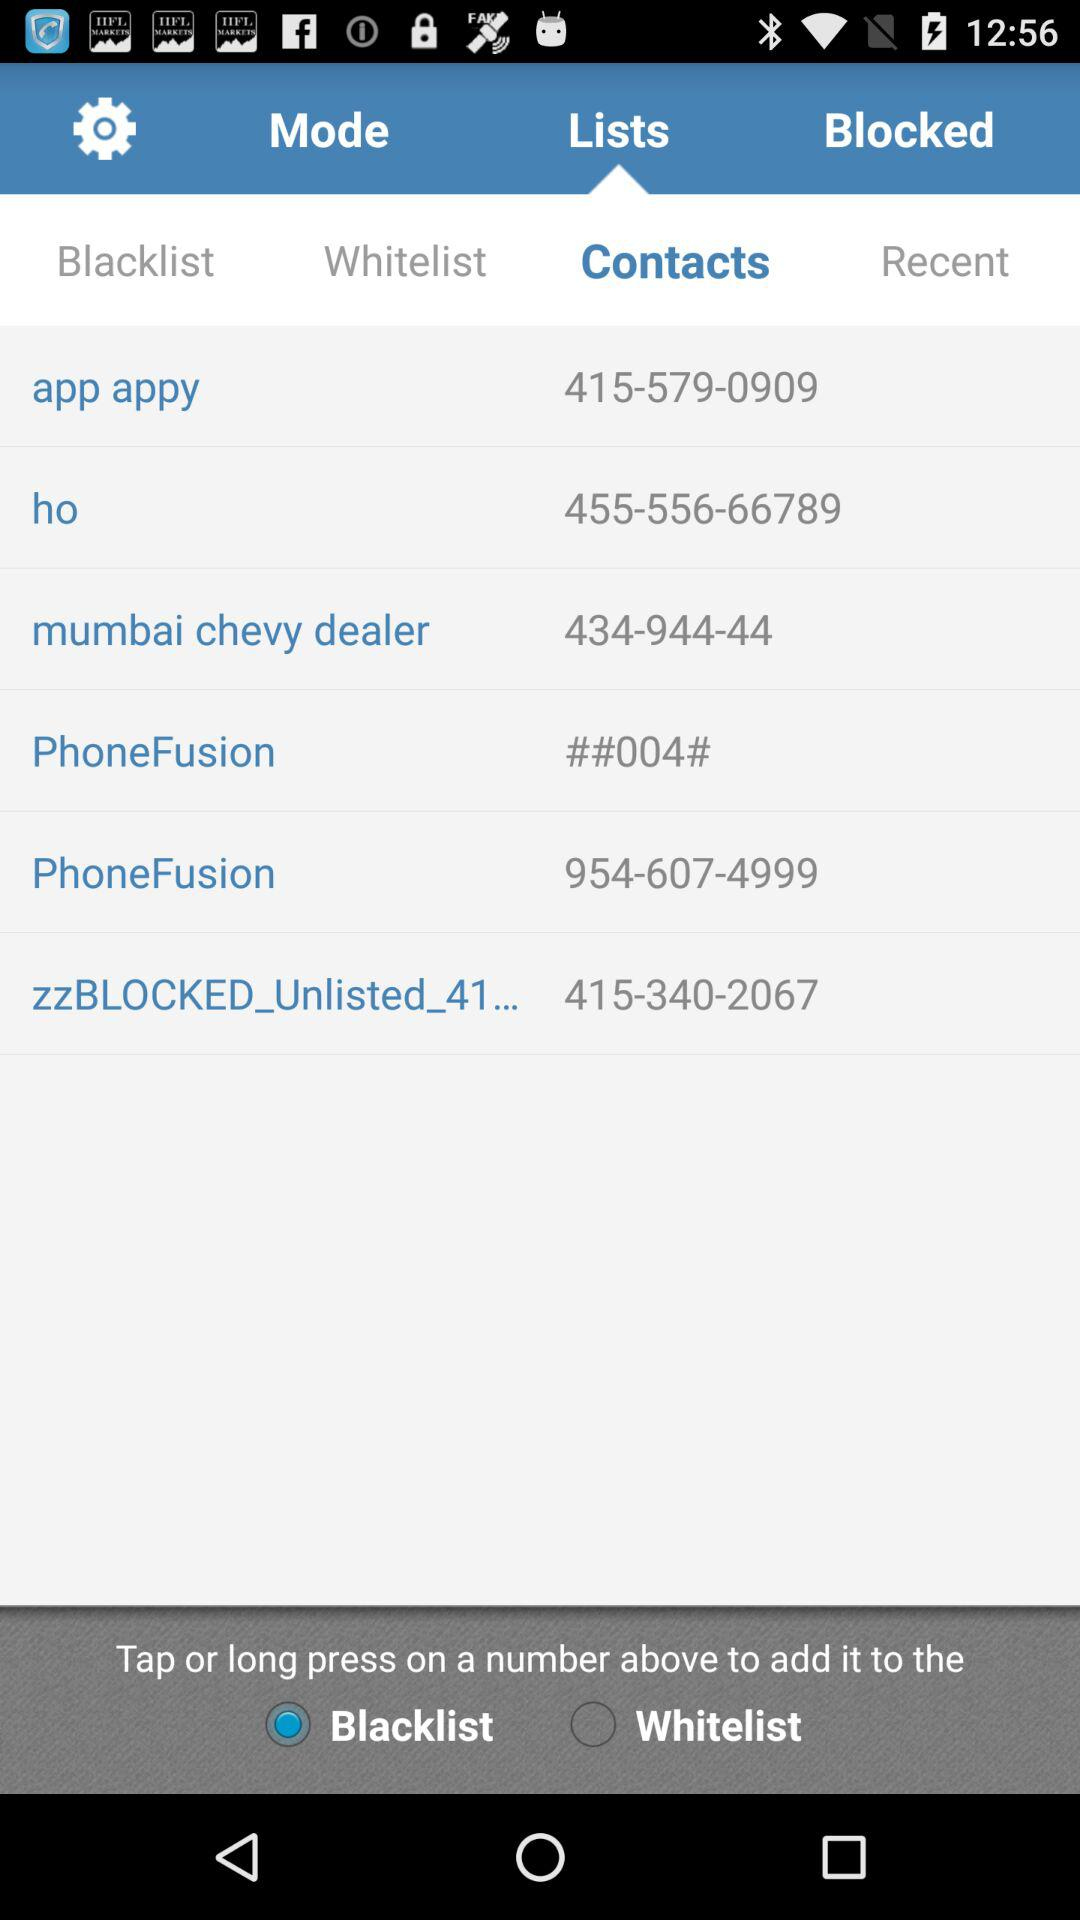What is the contact number of "ho"? The contact number of "ho" is 455-556-66789. 